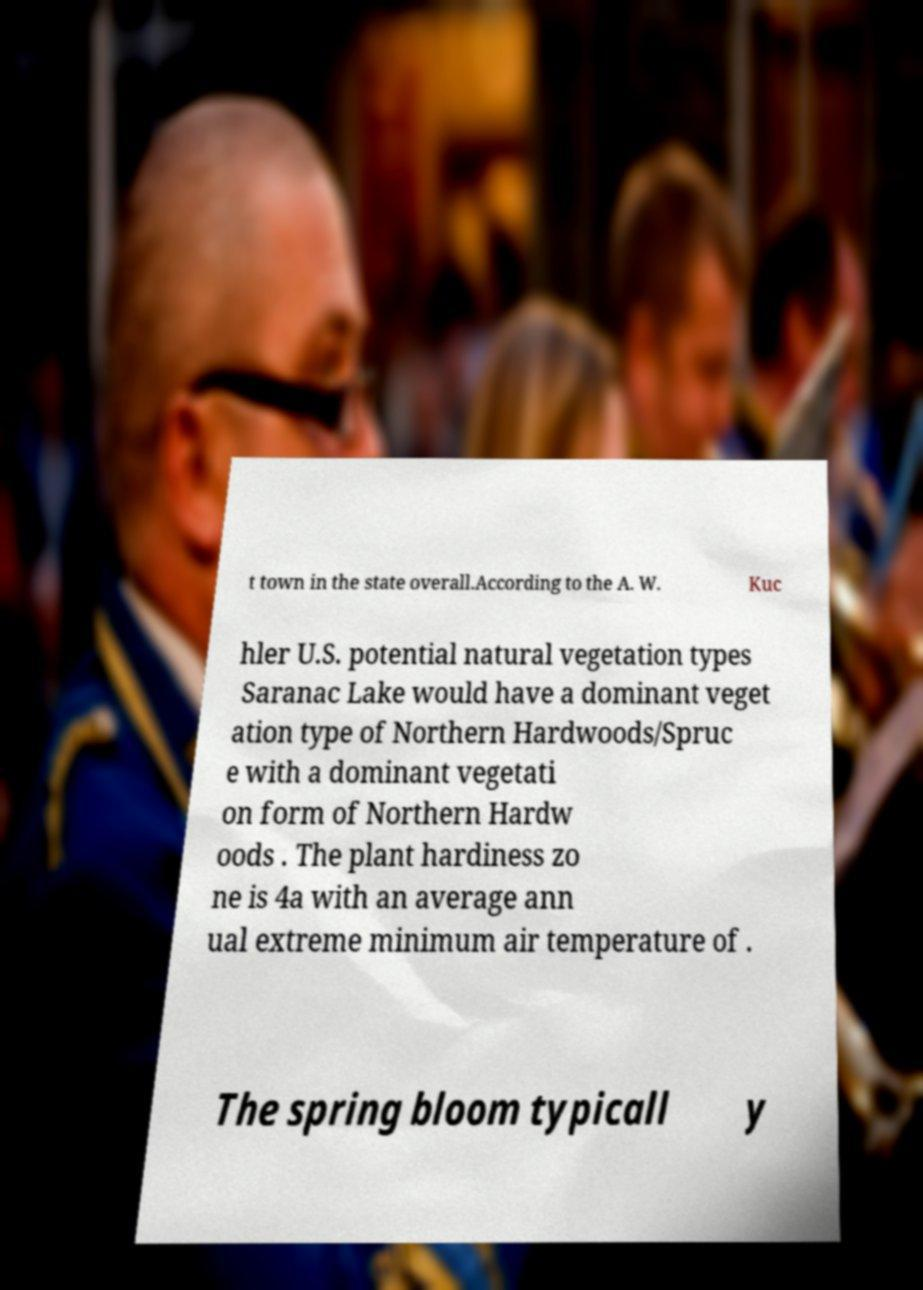There's text embedded in this image that I need extracted. Can you transcribe it verbatim? t town in the state overall.According to the A. W. Kuc hler U.S. potential natural vegetation types Saranac Lake would have a dominant veget ation type of Northern Hardwoods/Spruc e with a dominant vegetati on form of Northern Hardw oods . The plant hardiness zo ne is 4a with an average ann ual extreme minimum air temperature of . The spring bloom typicall y 